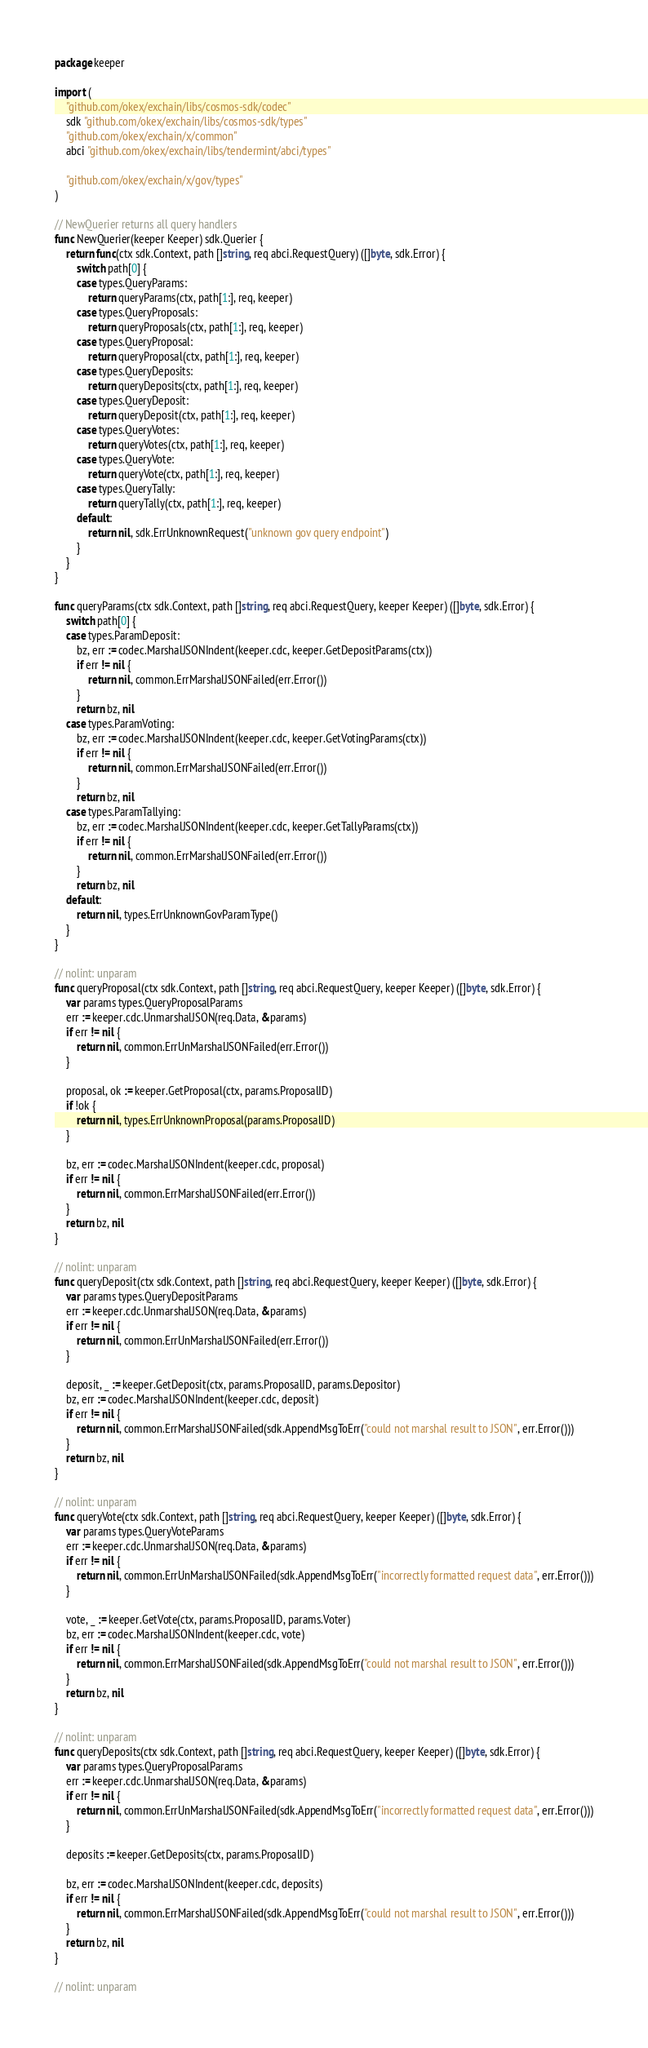Convert code to text. <code><loc_0><loc_0><loc_500><loc_500><_Go_>package keeper

import (
	"github.com/okex/exchain/libs/cosmos-sdk/codec"
	sdk "github.com/okex/exchain/libs/cosmos-sdk/types"
	"github.com/okex/exchain/x/common"
	abci "github.com/okex/exchain/libs/tendermint/abci/types"

	"github.com/okex/exchain/x/gov/types"
)

// NewQuerier returns all query handlers
func NewQuerier(keeper Keeper) sdk.Querier {
	return func(ctx sdk.Context, path []string, req abci.RequestQuery) ([]byte, sdk.Error) {
		switch path[0] {
		case types.QueryParams:
			return queryParams(ctx, path[1:], req, keeper)
		case types.QueryProposals:
			return queryProposals(ctx, path[1:], req, keeper)
		case types.QueryProposal:
			return queryProposal(ctx, path[1:], req, keeper)
		case types.QueryDeposits:
			return queryDeposits(ctx, path[1:], req, keeper)
		case types.QueryDeposit:
			return queryDeposit(ctx, path[1:], req, keeper)
		case types.QueryVotes:
			return queryVotes(ctx, path[1:], req, keeper)
		case types.QueryVote:
			return queryVote(ctx, path[1:], req, keeper)
		case types.QueryTally:
			return queryTally(ctx, path[1:], req, keeper)
		default:
			return nil, sdk.ErrUnknownRequest("unknown gov query endpoint")
		}
	}
}

func queryParams(ctx sdk.Context, path []string, req abci.RequestQuery, keeper Keeper) ([]byte, sdk.Error) {
	switch path[0] {
	case types.ParamDeposit:
		bz, err := codec.MarshalJSONIndent(keeper.cdc, keeper.GetDepositParams(ctx))
		if err != nil {
			return nil, common.ErrMarshalJSONFailed(err.Error())
		}
		return bz, nil
	case types.ParamVoting:
		bz, err := codec.MarshalJSONIndent(keeper.cdc, keeper.GetVotingParams(ctx))
		if err != nil {
			return nil, common.ErrMarshalJSONFailed(err.Error())
		}
		return bz, nil
	case types.ParamTallying:
		bz, err := codec.MarshalJSONIndent(keeper.cdc, keeper.GetTallyParams(ctx))
		if err != nil {
			return nil, common.ErrMarshalJSONFailed(err.Error())
		}
		return bz, nil
	default:
		return nil, types.ErrUnknownGovParamType()
	}
}

// nolint: unparam
func queryProposal(ctx sdk.Context, path []string, req abci.RequestQuery, keeper Keeper) ([]byte, sdk.Error) {
	var params types.QueryProposalParams
	err := keeper.cdc.UnmarshalJSON(req.Data, &params)
	if err != nil {
		return nil, common.ErrUnMarshalJSONFailed(err.Error())
	}

	proposal, ok := keeper.GetProposal(ctx, params.ProposalID)
	if !ok {
		return nil, types.ErrUnknownProposal(params.ProposalID)
	}

	bz, err := codec.MarshalJSONIndent(keeper.cdc, proposal)
	if err != nil {
		return nil, common.ErrMarshalJSONFailed(err.Error())
	}
	return bz, nil
}

// nolint: unparam
func queryDeposit(ctx sdk.Context, path []string, req abci.RequestQuery, keeper Keeper) ([]byte, sdk.Error) {
	var params types.QueryDepositParams
	err := keeper.cdc.UnmarshalJSON(req.Data, &params)
	if err != nil {
		return nil, common.ErrUnMarshalJSONFailed(err.Error())
	}

	deposit, _ := keeper.GetDeposit(ctx, params.ProposalID, params.Depositor)
	bz, err := codec.MarshalJSONIndent(keeper.cdc, deposit)
	if err != nil {
		return nil, common.ErrMarshalJSONFailed(sdk.AppendMsgToErr("could not marshal result to JSON", err.Error()))
	}
	return bz, nil
}

// nolint: unparam
func queryVote(ctx sdk.Context, path []string, req abci.RequestQuery, keeper Keeper) ([]byte, sdk.Error) {
	var params types.QueryVoteParams
	err := keeper.cdc.UnmarshalJSON(req.Data, &params)
	if err != nil {
		return nil, common.ErrUnMarshalJSONFailed(sdk.AppendMsgToErr("incorrectly formatted request data", err.Error()))
	}

	vote, _ := keeper.GetVote(ctx, params.ProposalID, params.Voter)
	bz, err := codec.MarshalJSONIndent(keeper.cdc, vote)
	if err != nil {
		return nil, common.ErrMarshalJSONFailed(sdk.AppendMsgToErr("could not marshal result to JSON", err.Error()))
	}
	return bz, nil
}

// nolint: unparam
func queryDeposits(ctx sdk.Context, path []string, req abci.RequestQuery, keeper Keeper) ([]byte, sdk.Error) {
	var params types.QueryProposalParams
	err := keeper.cdc.UnmarshalJSON(req.Data, &params)
	if err != nil {
		return nil, common.ErrUnMarshalJSONFailed(sdk.AppendMsgToErr("incorrectly formatted request data", err.Error()))
	}

	deposits := keeper.GetDeposits(ctx, params.ProposalID)

	bz, err := codec.MarshalJSONIndent(keeper.cdc, deposits)
	if err != nil {
		return nil, common.ErrMarshalJSONFailed(sdk.AppendMsgToErr("could not marshal result to JSON", err.Error()))
	}
	return bz, nil
}

// nolint: unparam</code> 